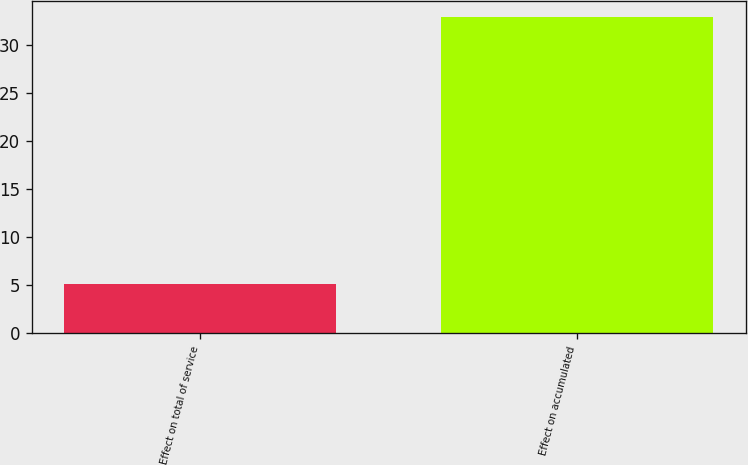Convert chart. <chart><loc_0><loc_0><loc_500><loc_500><bar_chart><fcel>Effect on total of service<fcel>Effect on accumulated<nl><fcel>5.1<fcel>33<nl></chart> 